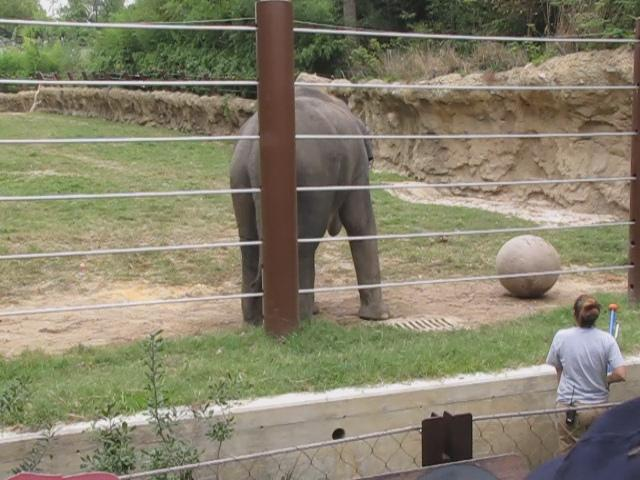How will she tell her supervisor about the welfare of the animal? walkie talkie 